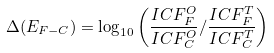<formula> <loc_0><loc_0><loc_500><loc_500>\Delta ( E _ { F - C } ) = \log _ { 1 0 } \left ( \frac { I C F _ { F } ^ { O } } { I C F _ { C } ^ { O } } / \frac { I C F _ { F } ^ { T } } { I C F _ { C } ^ { T } } \right )</formula> 